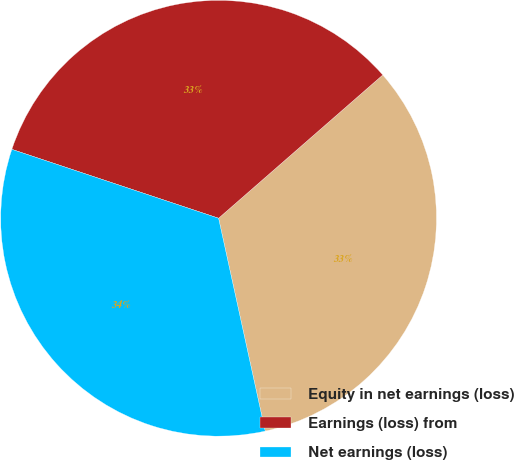<chart> <loc_0><loc_0><loc_500><loc_500><pie_chart><fcel>Equity in net earnings (loss)<fcel>Earnings (loss) from<fcel>Net earnings (loss)<nl><fcel>32.99%<fcel>33.46%<fcel>33.55%<nl></chart> 